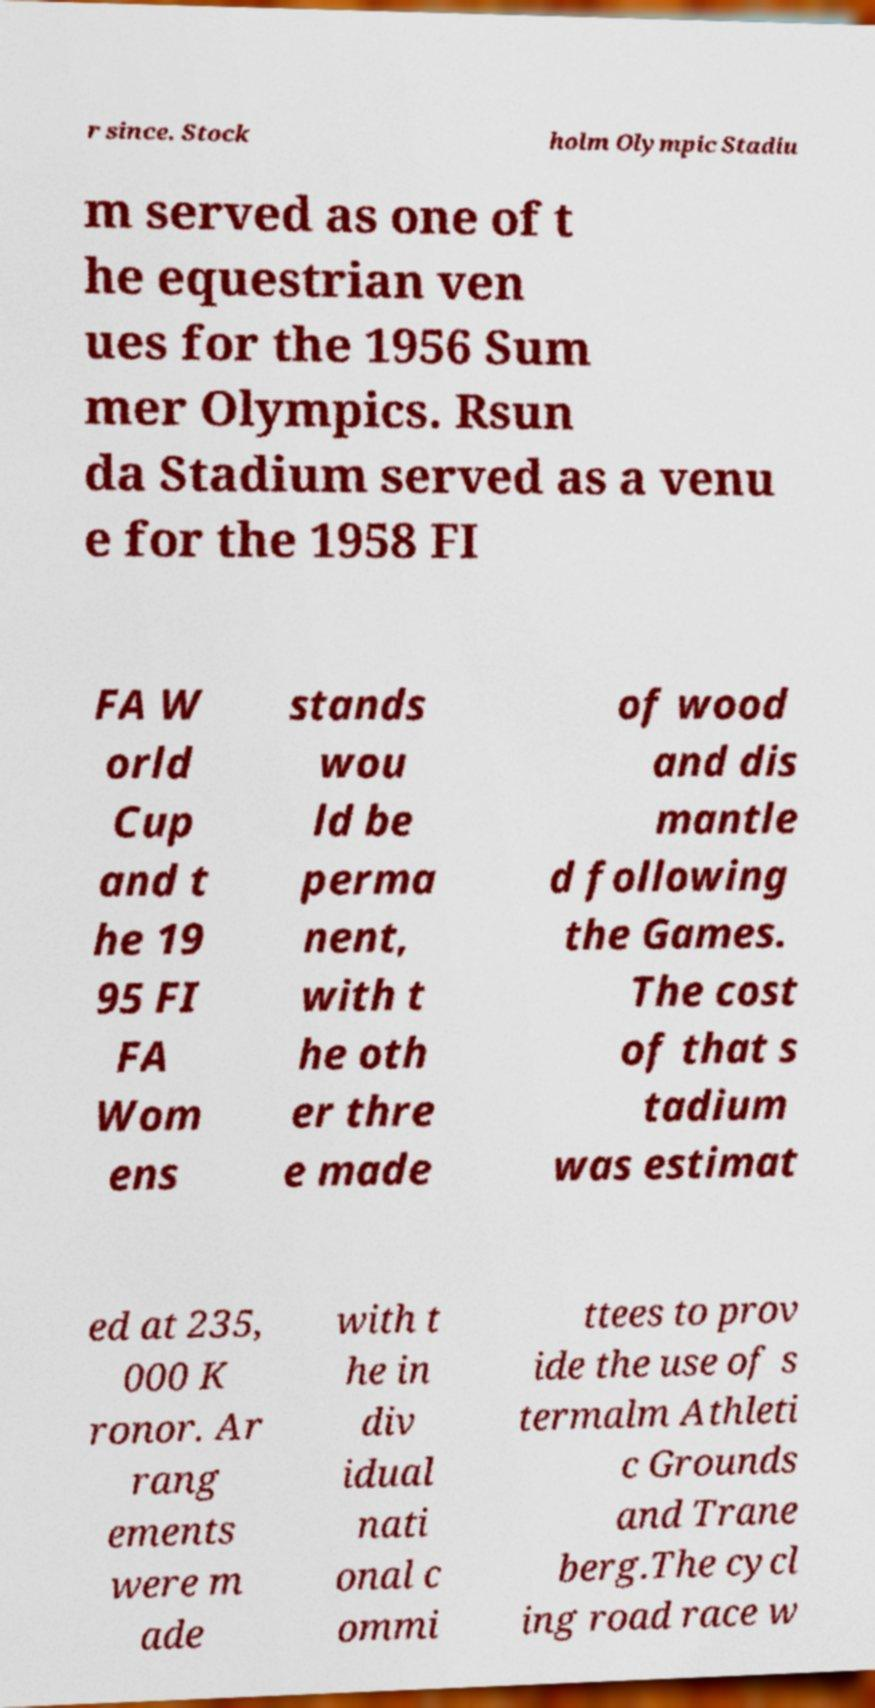Can you accurately transcribe the text from the provided image for me? r since. Stock holm Olympic Stadiu m served as one of t he equestrian ven ues for the 1956 Sum mer Olympics. Rsun da Stadium served as a venu e for the 1958 FI FA W orld Cup and t he 19 95 FI FA Wom ens stands wou ld be perma nent, with t he oth er thre e made of wood and dis mantle d following the Games. The cost of that s tadium was estimat ed at 235, 000 K ronor. Ar rang ements were m ade with t he in div idual nati onal c ommi ttees to prov ide the use of s termalm Athleti c Grounds and Trane berg.The cycl ing road race w 